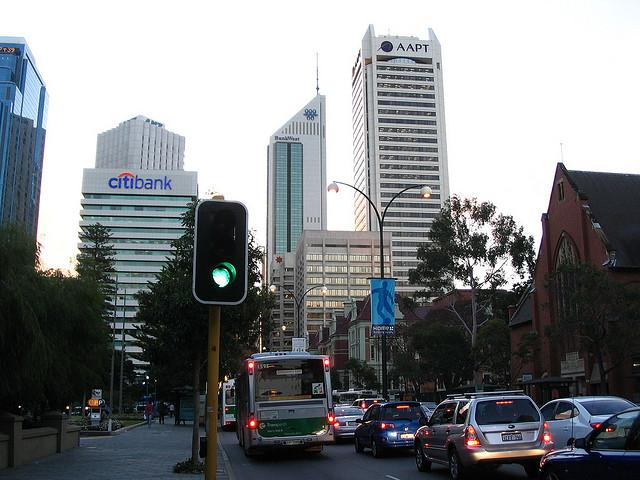Who designed the first building's logo? citibank 